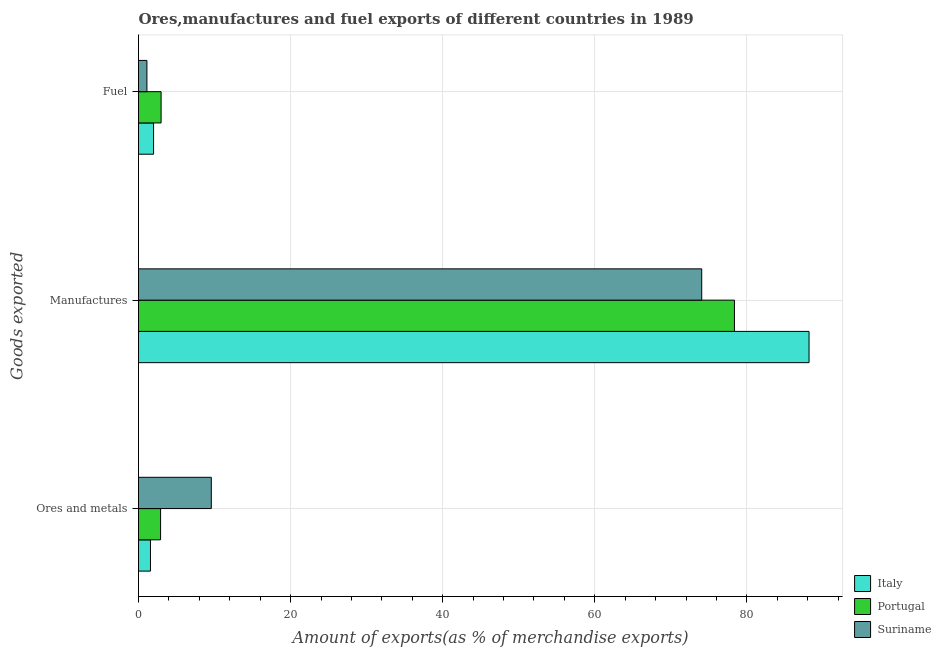How many different coloured bars are there?
Provide a succinct answer. 3. How many groups of bars are there?
Give a very brief answer. 3. Are the number of bars on each tick of the Y-axis equal?
Your answer should be very brief. Yes. What is the label of the 1st group of bars from the top?
Offer a very short reply. Fuel. What is the percentage of fuel exports in Suriname?
Your response must be concise. 1.11. Across all countries, what is the maximum percentage of fuel exports?
Keep it short and to the point. 2.97. Across all countries, what is the minimum percentage of fuel exports?
Provide a succinct answer. 1.11. In which country was the percentage of ores and metals exports maximum?
Keep it short and to the point. Suriname. What is the total percentage of manufactures exports in the graph?
Your answer should be compact. 240.62. What is the difference between the percentage of manufactures exports in Italy and that in Portugal?
Provide a succinct answer. 9.81. What is the difference between the percentage of fuel exports in Italy and the percentage of manufactures exports in Portugal?
Provide a short and direct response. -76.39. What is the average percentage of ores and metals exports per country?
Keep it short and to the point. 4.68. What is the difference between the percentage of fuel exports and percentage of ores and metals exports in Portugal?
Provide a short and direct response. 0.07. What is the ratio of the percentage of ores and metals exports in Portugal to that in Suriname?
Ensure brevity in your answer.  0.3. What is the difference between the highest and the second highest percentage of manufactures exports?
Provide a succinct answer. 9.81. What is the difference between the highest and the lowest percentage of ores and metals exports?
Provide a succinct answer. 8. In how many countries, is the percentage of manufactures exports greater than the average percentage of manufactures exports taken over all countries?
Your answer should be compact. 1. Is the sum of the percentage of ores and metals exports in Italy and Portugal greater than the maximum percentage of manufactures exports across all countries?
Offer a very short reply. No. What does the 3rd bar from the top in Manufactures represents?
Your answer should be compact. Italy. What does the 1st bar from the bottom in Fuel represents?
Your answer should be very brief. Italy. How many bars are there?
Give a very brief answer. 9. Are all the bars in the graph horizontal?
Your answer should be compact. Yes. Are the values on the major ticks of X-axis written in scientific E-notation?
Provide a succinct answer. No. What is the title of the graph?
Give a very brief answer. Ores,manufactures and fuel exports of different countries in 1989. What is the label or title of the X-axis?
Offer a terse response. Amount of exports(as % of merchandise exports). What is the label or title of the Y-axis?
Ensure brevity in your answer.  Goods exported. What is the Amount of exports(as % of merchandise exports) of Italy in Ores and metals?
Provide a succinct answer. 1.57. What is the Amount of exports(as % of merchandise exports) of Portugal in Ores and metals?
Provide a succinct answer. 2.9. What is the Amount of exports(as % of merchandise exports) of Suriname in Ores and metals?
Make the answer very short. 9.57. What is the Amount of exports(as % of merchandise exports) in Italy in Manufactures?
Ensure brevity in your answer.  88.18. What is the Amount of exports(as % of merchandise exports) in Portugal in Manufactures?
Provide a short and direct response. 78.37. What is the Amount of exports(as % of merchandise exports) of Suriname in Manufactures?
Your response must be concise. 74.07. What is the Amount of exports(as % of merchandise exports) of Italy in Fuel?
Your answer should be very brief. 1.98. What is the Amount of exports(as % of merchandise exports) of Portugal in Fuel?
Your answer should be compact. 2.97. What is the Amount of exports(as % of merchandise exports) of Suriname in Fuel?
Keep it short and to the point. 1.11. Across all Goods exported, what is the maximum Amount of exports(as % of merchandise exports) of Italy?
Your answer should be very brief. 88.18. Across all Goods exported, what is the maximum Amount of exports(as % of merchandise exports) of Portugal?
Provide a short and direct response. 78.37. Across all Goods exported, what is the maximum Amount of exports(as % of merchandise exports) of Suriname?
Ensure brevity in your answer.  74.07. Across all Goods exported, what is the minimum Amount of exports(as % of merchandise exports) of Italy?
Ensure brevity in your answer.  1.57. Across all Goods exported, what is the minimum Amount of exports(as % of merchandise exports) in Portugal?
Your answer should be very brief. 2.9. Across all Goods exported, what is the minimum Amount of exports(as % of merchandise exports) of Suriname?
Provide a short and direct response. 1.11. What is the total Amount of exports(as % of merchandise exports) in Italy in the graph?
Offer a terse response. 91.74. What is the total Amount of exports(as % of merchandise exports) of Portugal in the graph?
Provide a short and direct response. 84.24. What is the total Amount of exports(as % of merchandise exports) in Suriname in the graph?
Your answer should be compact. 84.75. What is the difference between the Amount of exports(as % of merchandise exports) in Italy in Ores and metals and that in Manufactures?
Provide a short and direct response. -86.61. What is the difference between the Amount of exports(as % of merchandise exports) of Portugal in Ores and metals and that in Manufactures?
Provide a succinct answer. -75.47. What is the difference between the Amount of exports(as % of merchandise exports) in Suriname in Ores and metals and that in Manufactures?
Keep it short and to the point. -64.49. What is the difference between the Amount of exports(as % of merchandise exports) in Italy in Ores and metals and that in Fuel?
Your answer should be very brief. -0.41. What is the difference between the Amount of exports(as % of merchandise exports) in Portugal in Ores and metals and that in Fuel?
Offer a very short reply. -0.07. What is the difference between the Amount of exports(as % of merchandise exports) of Suriname in Ores and metals and that in Fuel?
Your answer should be very brief. 8.47. What is the difference between the Amount of exports(as % of merchandise exports) of Italy in Manufactures and that in Fuel?
Your answer should be very brief. 86.2. What is the difference between the Amount of exports(as % of merchandise exports) of Portugal in Manufactures and that in Fuel?
Give a very brief answer. 75.4. What is the difference between the Amount of exports(as % of merchandise exports) of Suriname in Manufactures and that in Fuel?
Provide a succinct answer. 72.96. What is the difference between the Amount of exports(as % of merchandise exports) in Italy in Ores and metals and the Amount of exports(as % of merchandise exports) in Portugal in Manufactures?
Give a very brief answer. -76.8. What is the difference between the Amount of exports(as % of merchandise exports) in Italy in Ores and metals and the Amount of exports(as % of merchandise exports) in Suriname in Manufactures?
Give a very brief answer. -72.49. What is the difference between the Amount of exports(as % of merchandise exports) in Portugal in Ores and metals and the Amount of exports(as % of merchandise exports) in Suriname in Manufactures?
Your answer should be very brief. -71.16. What is the difference between the Amount of exports(as % of merchandise exports) of Italy in Ores and metals and the Amount of exports(as % of merchandise exports) of Portugal in Fuel?
Ensure brevity in your answer.  -1.4. What is the difference between the Amount of exports(as % of merchandise exports) in Italy in Ores and metals and the Amount of exports(as % of merchandise exports) in Suriname in Fuel?
Keep it short and to the point. 0.47. What is the difference between the Amount of exports(as % of merchandise exports) in Portugal in Ores and metals and the Amount of exports(as % of merchandise exports) in Suriname in Fuel?
Ensure brevity in your answer.  1.8. What is the difference between the Amount of exports(as % of merchandise exports) in Italy in Manufactures and the Amount of exports(as % of merchandise exports) in Portugal in Fuel?
Provide a short and direct response. 85.21. What is the difference between the Amount of exports(as % of merchandise exports) in Italy in Manufactures and the Amount of exports(as % of merchandise exports) in Suriname in Fuel?
Offer a terse response. 87.07. What is the difference between the Amount of exports(as % of merchandise exports) of Portugal in Manufactures and the Amount of exports(as % of merchandise exports) of Suriname in Fuel?
Offer a very short reply. 77.26. What is the average Amount of exports(as % of merchandise exports) in Italy per Goods exported?
Ensure brevity in your answer.  30.58. What is the average Amount of exports(as % of merchandise exports) of Portugal per Goods exported?
Offer a terse response. 28.08. What is the average Amount of exports(as % of merchandise exports) in Suriname per Goods exported?
Give a very brief answer. 28.25. What is the difference between the Amount of exports(as % of merchandise exports) in Italy and Amount of exports(as % of merchandise exports) in Portugal in Ores and metals?
Provide a succinct answer. -1.33. What is the difference between the Amount of exports(as % of merchandise exports) of Italy and Amount of exports(as % of merchandise exports) of Suriname in Ores and metals?
Offer a very short reply. -8. What is the difference between the Amount of exports(as % of merchandise exports) of Portugal and Amount of exports(as % of merchandise exports) of Suriname in Ores and metals?
Offer a terse response. -6.67. What is the difference between the Amount of exports(as % of merchandise exports) in Italy and Amount of exports(as % of merchandise exports) in Portugal in Manufactures?
Give a very brief answer. 9.81. What is the difference between the Amount of exports(as % of merchandise exports) in Italy and Amount of exports(as % of merchandise exports) in Suriname in Manufactures?
Offer a very short reply. 14.12. What is the difference between the Amount of exports(as % of merchandise exports) of Portugal and Amount of exports(as % of merchandise exports) of Suriname in Manufactures?
Offer a terse response. 4.3. What is the difference between the Amount of exports(as % of merchandise exports) of Italy and Amount of exports(as % of merchandise exports) of Portugal in Fuel?
Offer a terse response. -0.99. What is the difference between the Amount of exports(as % of merchandise exports) in Italy and Amount of exports(as % of merchandise exports) in Suriname in Fuel?
Your answer should be very brief. 0.88. What is the difference between the Amount of exports(as % of merchandise exports) of Portugal and Amount of exports(as % of merchandise exports) of Suriname in Fuel?
Give a very brief answer. 1.86. What is the ratio of the Amount of exports(as % of merchandise exports) in Italy in Ores and metals to that in Manufactures?
Provide a succinct answer. 0.02. What is the ratio of the Amount of exports(as % of merchandise exports) in Portugal in Ores and metals to that in Manufactures?
Offer a very short reply. 0.04. What is the ratio of the Amount of exports(as % of merchandise exports) of Suriname in Ores and metals to that in Manufactures?
Provide a succinct answer. 0.13. What is the ratio of the Amount of exports(as % of merchandise exports) in Italy in Ores and metals to that in Fuel?
Provide a short and direct response. 0.79. What is the ratio of the Amount of exports(as % of merchandise exports) of Portugal in Ores and metals to that in Fuel?
Offer a very short reply. 0.98. What is the ratio of the Amount of exports(as % of merchandise exports) of Suriname in Ores and metals to that in Fuel?
Your response must be concise. 8.65. What is the ratio of the Amount of exports(as % of merchandise exports) in Italy in Manufactures to that in Fuel?
Ensure brevity in your answer.  44.49. What is the ratio of the Amount of exports(as % of merchandise exports) in Portugal in Manufactures to that in Fuel?
Give a very brief answer. 26.38. What is the ratio of the Amount of exports(as % of merchandise exports) of Suriname in Manufactures to that in Fuel?
Your answer should be compact. 66.89. What is the difference between the highest and the second highest Amount of exports(as % of merchandise exports) of Italy?
Your answer should be compact. 86.2. What is the difference between the highest and the second highest Amount of exports(as % of merchandise exports) of Portugal?
Ensure brevity in your answer.  75.4. What is the difference between the highest and the second highest Amount of exports(as % of merchandise exports) of Suriname?
Give a very brief answer. 64.49. What is the difference between the highest and the lowest Amount of exports(as % of merchandise exports) in Italy?
Give a very brief answer. 86.61. What is the difference between the highest and the lowest Amount of exports(as % of merchandise exports) of Portugal?
Keep it short and to the point. 75.47. What is the difference between the highest and the lowest Amount of exports(as % of merchandise exports) of Suriname?
Your response must be concise. 72.96. 